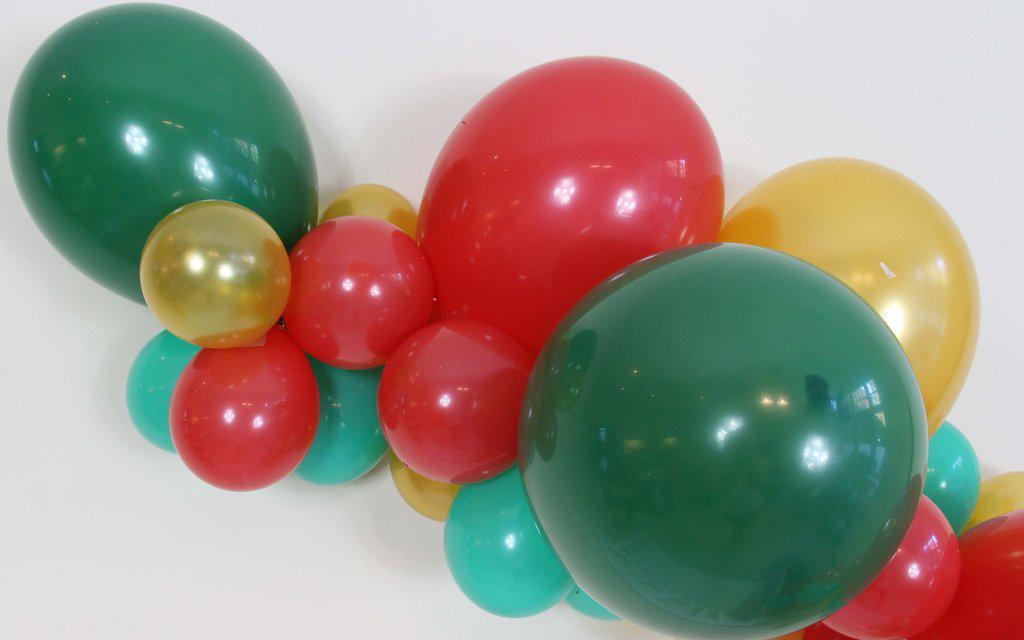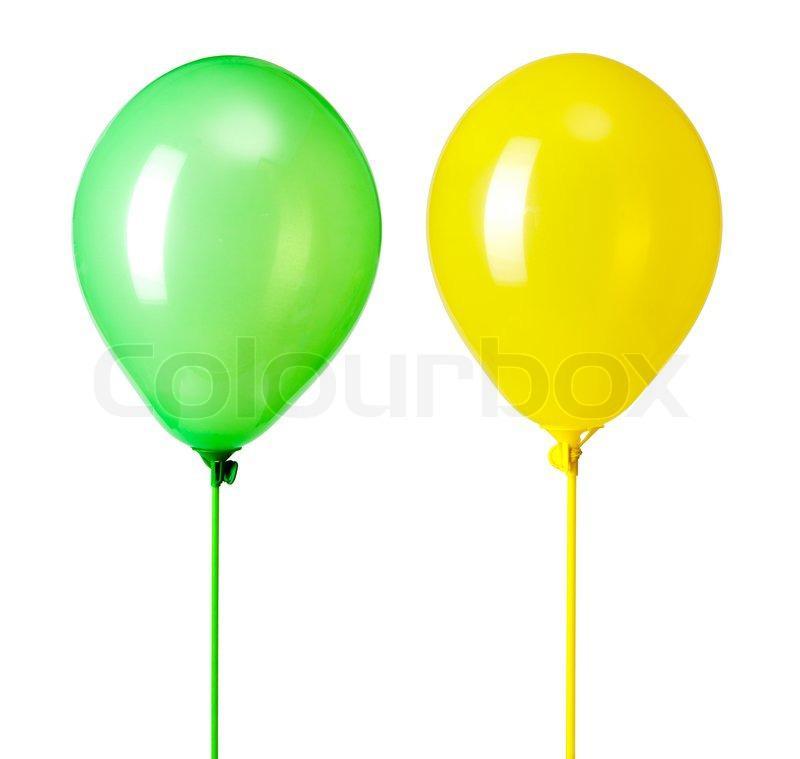The first image is the image on the left, the second image is the image on the right. Evaluate the accuracy of this statement regarding the images: "There are two red balloons out of the four shown.". Is it true? Answer yes or no. No. 